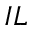<formula> <loc_0><loc_0><loc_500><loc_500>I L</formula> 